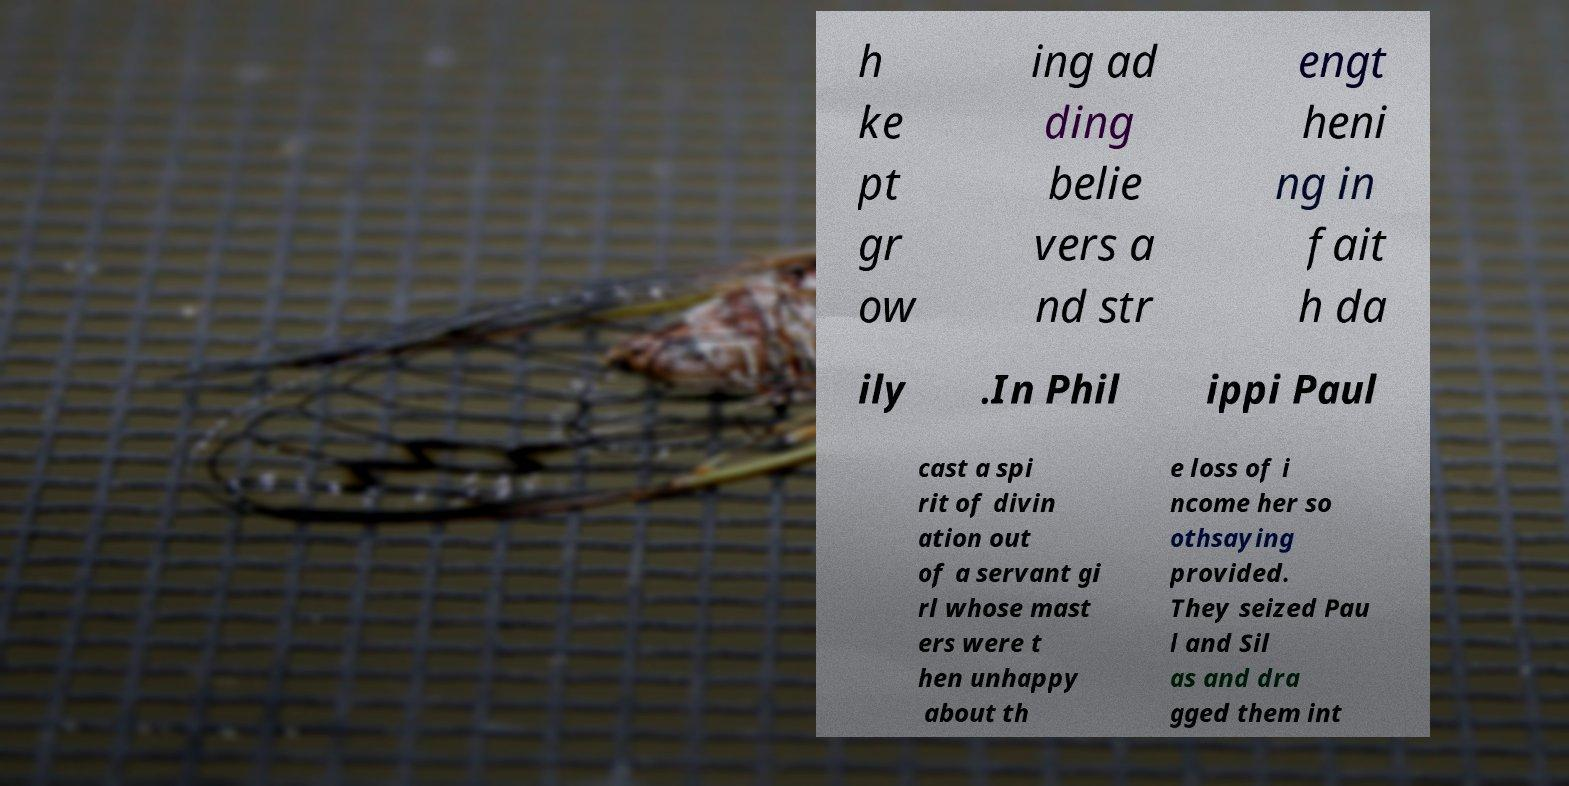What messages or text are displayed in this image? I need them in a readable, typed format. h ke pt gr ow ing ad ding belie vers a nd str engt heni ng in fait h da ily .In Phil ippi Paul cast a spi rit of divin ation out of a servant gi rl whose mast ers were t hen unhappy about th e loss of i ncome her so othsaying provided. They seized Pau l and Sil as and dra gged them int 